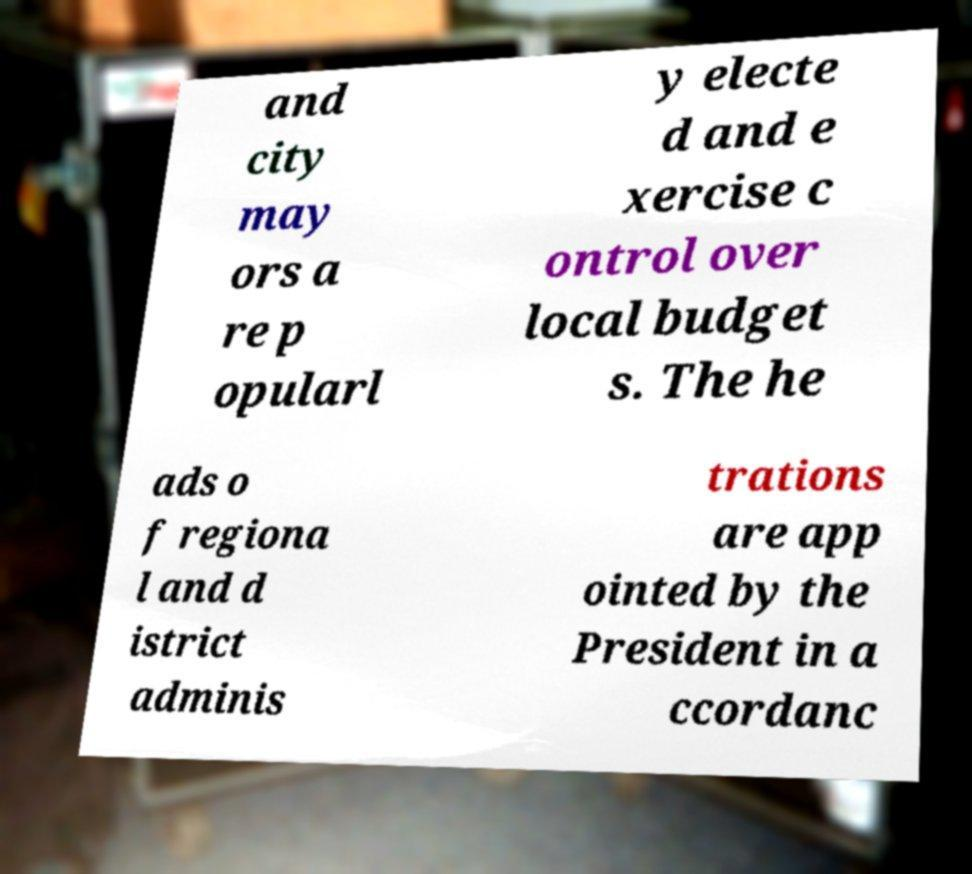Could you assist in decoding the text presented in this image and type it out clearly? and city may ors a re p opularl y electe d and e xercise c ontrol over local budget s. The he ads o f regiona l and d istrict adminis trations are app ointed by the President in a ccordanc 